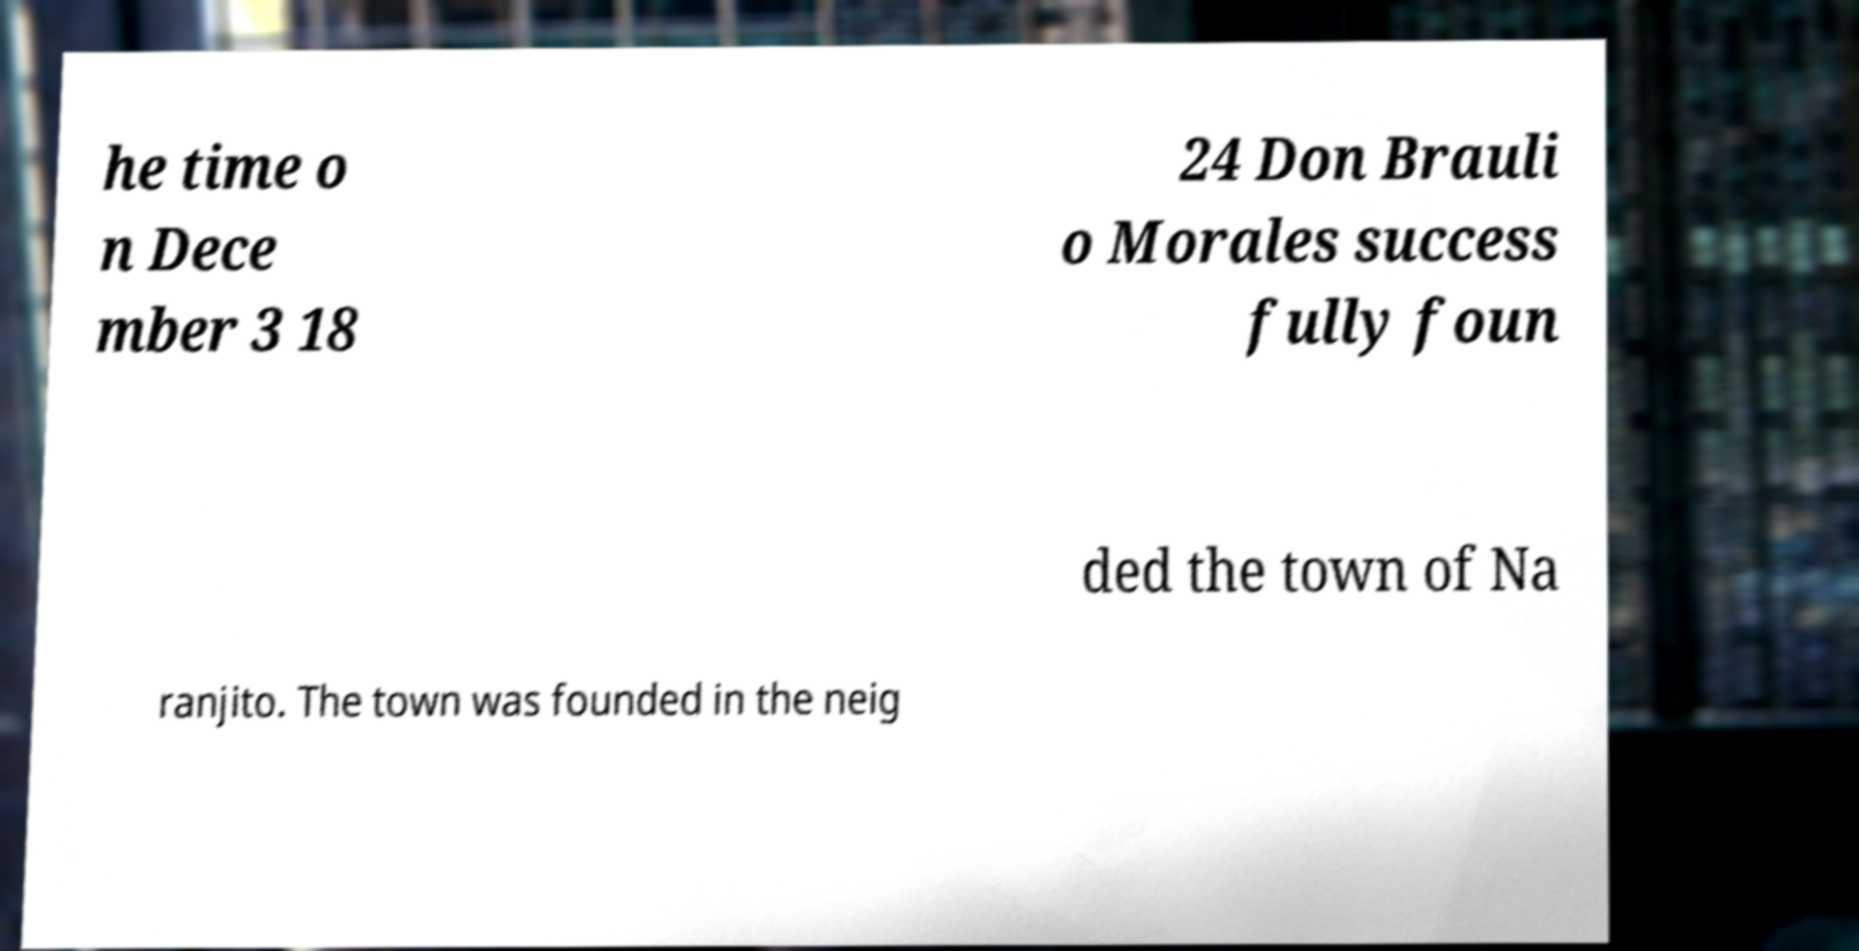Can you read and provide the text displayed in the image?This photo seems to have some interesting text. Can you extract and type it out for me? he time o n Dece mber 3 18 24 Don Brauli o Morales success fully foun ded the town of Na ranjito. The town was founded in the neig 